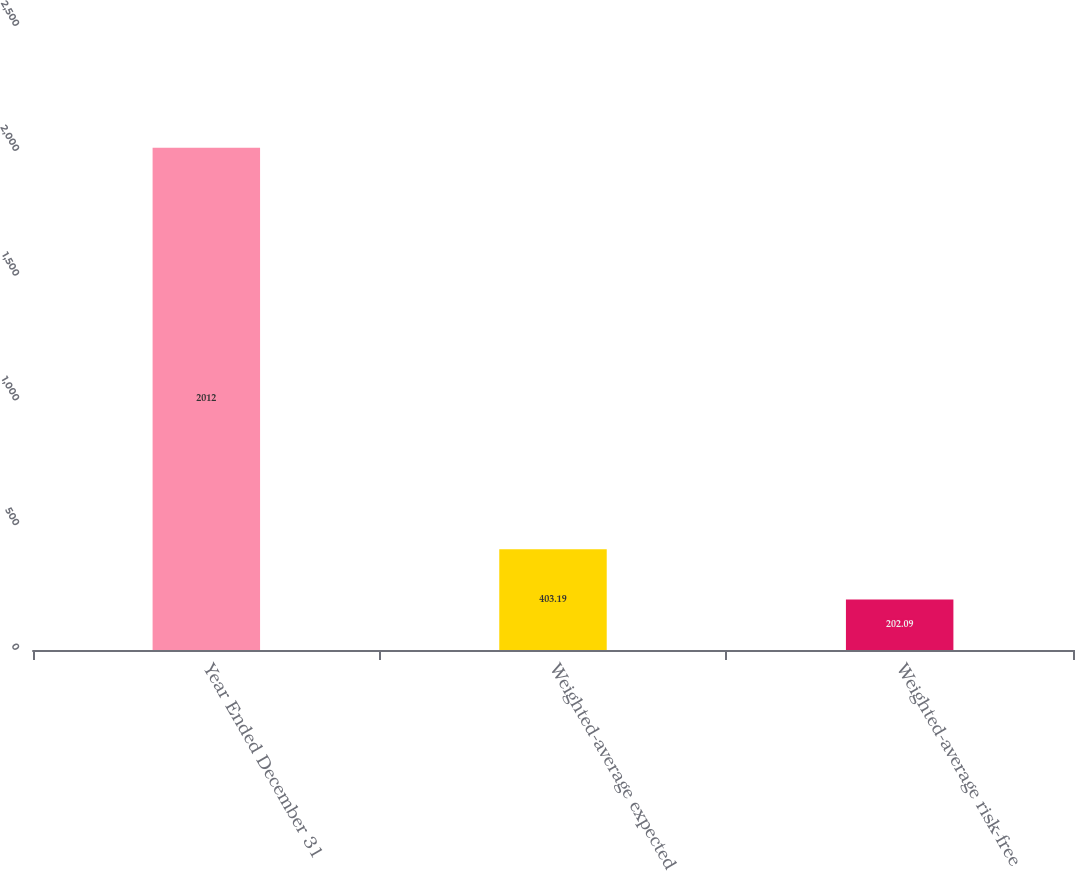Convert chart. <chart><loc_0><loc_0><loc_500><loc_500><bar_chart><fcel>Year Ended December 31<fcel>Weighted-average expected<fcel>Weighted-average risk-free<nl><fcel>2012<fcel>403.19<fcel>202.09<nl></chart> 